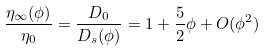<formula> <loc_0><loc_0><loc_500><loc_500>\frac { \eta _ { \infty } ( \phi ) } { \eta _ { 0 } } = \frac { D _ { 0 } } { D _ { s } ( \phi ) } = 1 + \frac { 5 } { 2 } \phi + O ( \phi ^ { 2 } )</formula> 